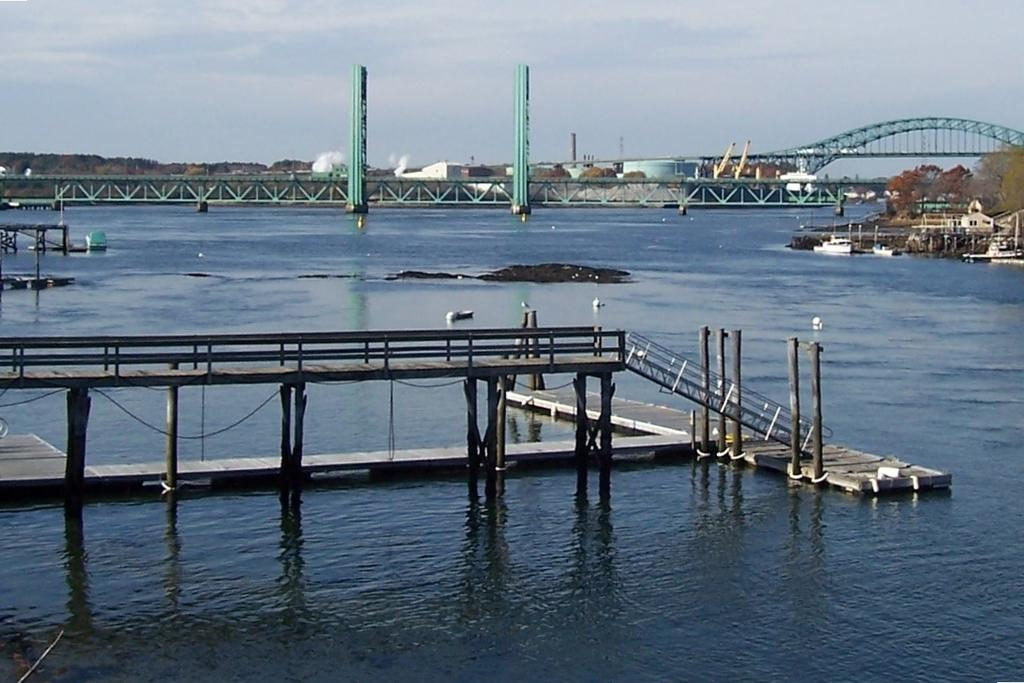What structure is featured in the image? There is a bridge in the image. What is the bridge positioned over? The bridge is over the sea. What else can be seen in the image besides the bridge? There are boats, buildings, trees, and a clear sky visible in the image. What type of straw is being used to answer questions about the image? There is no straw present in the image, and the image does not contain any questions to be answered. 